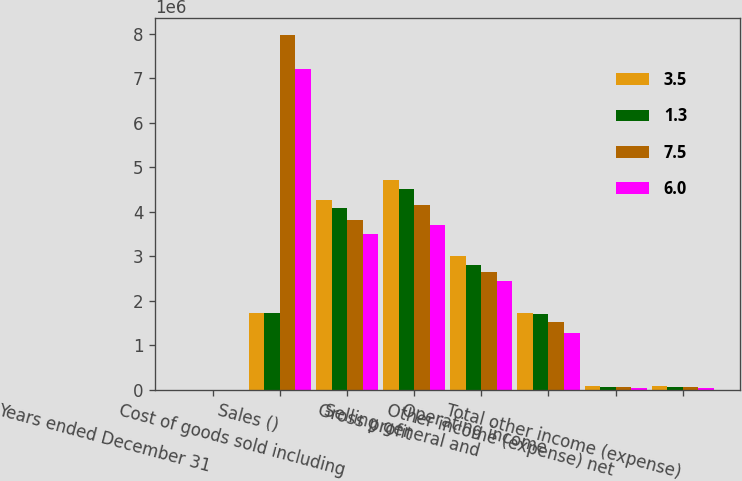Convert chart. <chart><loc_0><loc_0><loc_500><loc_500><stacked_bar_chart><ecel><fcel>Years ended December 31<fcel>Sales ()<fcel>Cost of goods sold including<fcel>Gross profit<fcel>Selling general and<fcel>Operating income<fcel>Other income (expense) net<fcel>Total other income (expense)<nl><fcel>3.5<fcel>2017<fcel>1.7123e+06<fcel>4.25704e+06<fcel>4.72068e+06<fcel>2.99528e+06<fcel>1.7254e+06<fcel>87596<fcel>87596<nl><fcel>1.3<fcel>2016<fcel>1.7123e+06<fcel>4.08408e+06<fcel>4.50901e+06<fcel>2.8098e+06<fcel>1.69921e+06<fcel>62015<fcel>62015<nl><fcel>7.5<fcel>2015<fcel>7.96667e+06<fcel>3.80403e+06<fcel>4.16264e+06<fcel>2.64862e+06<fcel>1.51402e+06<fcel>53655<fcel>53655<nl><fcel>6<fcel>2014<fcel>7.21608e+06<fcel>3.50718e+06<fcel>3.7089e+06<fcel>2.43853e+06<fcel>1.27037e+06<fcel>48192<fcel>48192<nl></chart> 